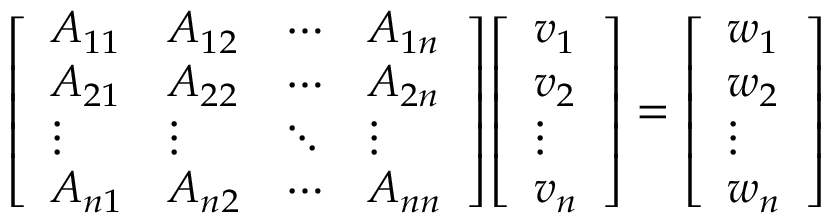Convert formula to latex. <formula><loc_0><loc_0><loc_500><loc_500>{ \left [ \begin{array} { l l l l } { A _ { 1 1 } } & { A _ { 1 2 } } & { \cdots } & { A _ { 1 n } } \\ { A _ { 2 1 } } & { A _ { 2 2 } } & { \cdots } & { A _ { 2 n } } \\ { \vdots } & { \vdots } & { \ddots } & { \vdots } \\ { A _ { n 1 } } & { A _ { n 2 } } & { \cdots } & { A _ { n n } } \end{array} \right ] } { \left [ \begin{array} { l } { v _ { 1 } } \\ { v _ { 2 } } \\ { \vdots } \\ { v _ { n } } \end{array} \right ] } = { \left [ \begin{array} { l } { w _ { 1 } } \\ { w _ { 2 } } \\ { \vdots } \\ { w _ { n } } \end{array} \right ] }</formula> 